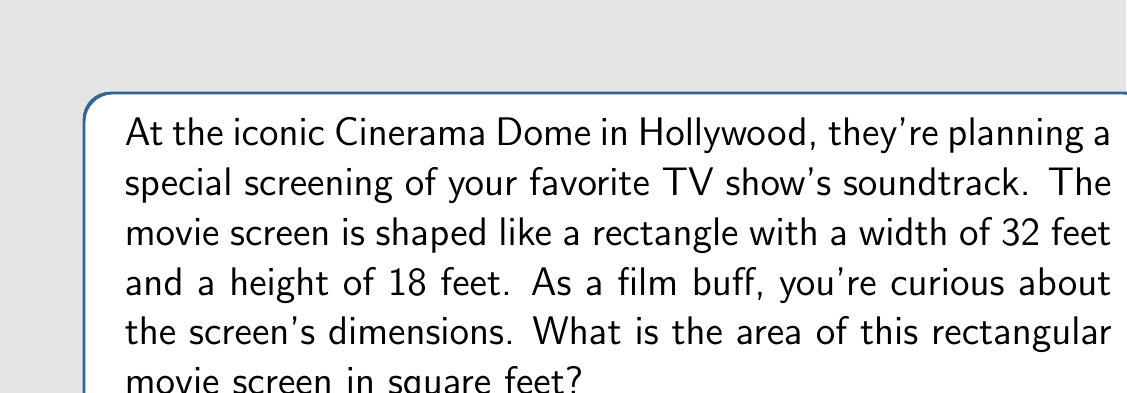Can you answer this question? To calculate the area of a rectangular movie screen, we need to multiply its width by its height. Let's break it down step-by-step:

1. Given dimensions:
   Width (w) = 32 feet
   Height (h) = 18 feet

2. The formula for the area of a rectangle is:
   $$A = w \times h$$

3. Substituting the given values:
   $$A = 32 \text{ ft} \times 18 \text{ ft}$$

4. Multiplying the numbers:
   $$A = 576 \text{ ft}^2$$

Therefore, the area of the movie screen is 576 square feet.
Answer: 576 ft² 